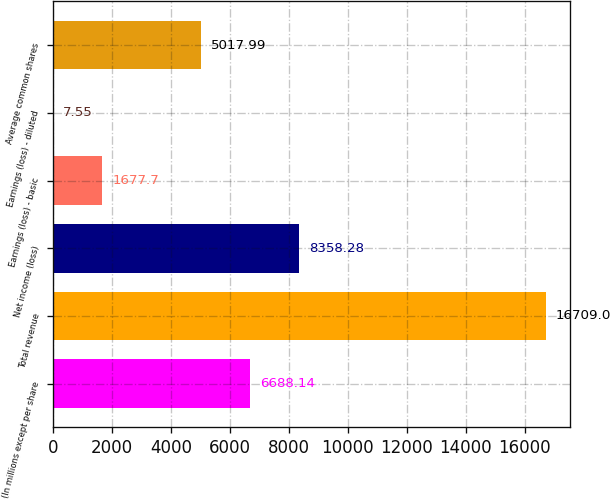<chart> <loc_0><loc_0><loc_500><loc_500><bar_chart><fcel>(In millions except per share<fcel>Total revenue<fcel>Net income (loss)<fcel>Earnings (loss) - basic<fcel>Earnings (loss) - diluted<fcel>Average common shares<nl><fcel>6688.14<fcel>16709<fcel>8358.28<fcel>1677.7<fcel>7.55<fcel>5017.99<nl></chart> 